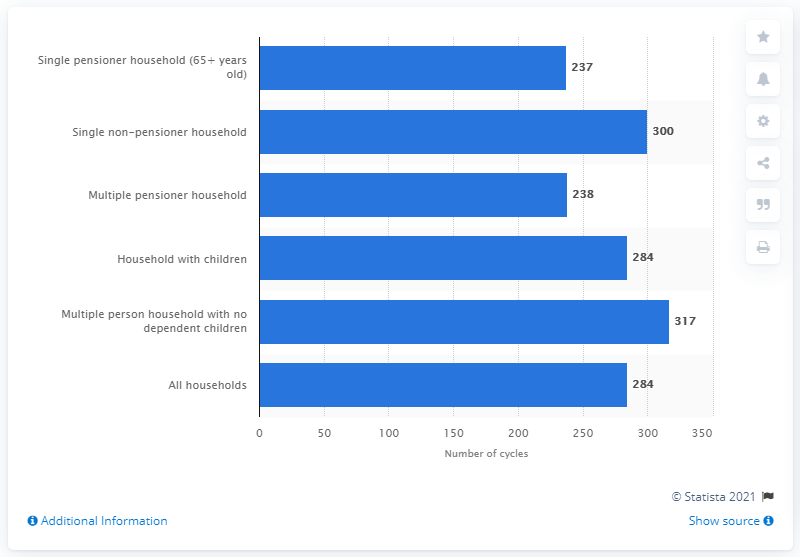Identify some key points in this picture. In 2020, the average single non-pensioner household in the UK had approximately 300 washing machine cycles per year. In 2011, multiple person households without dependent children showed an average of 317 washing machine cycles per month. 